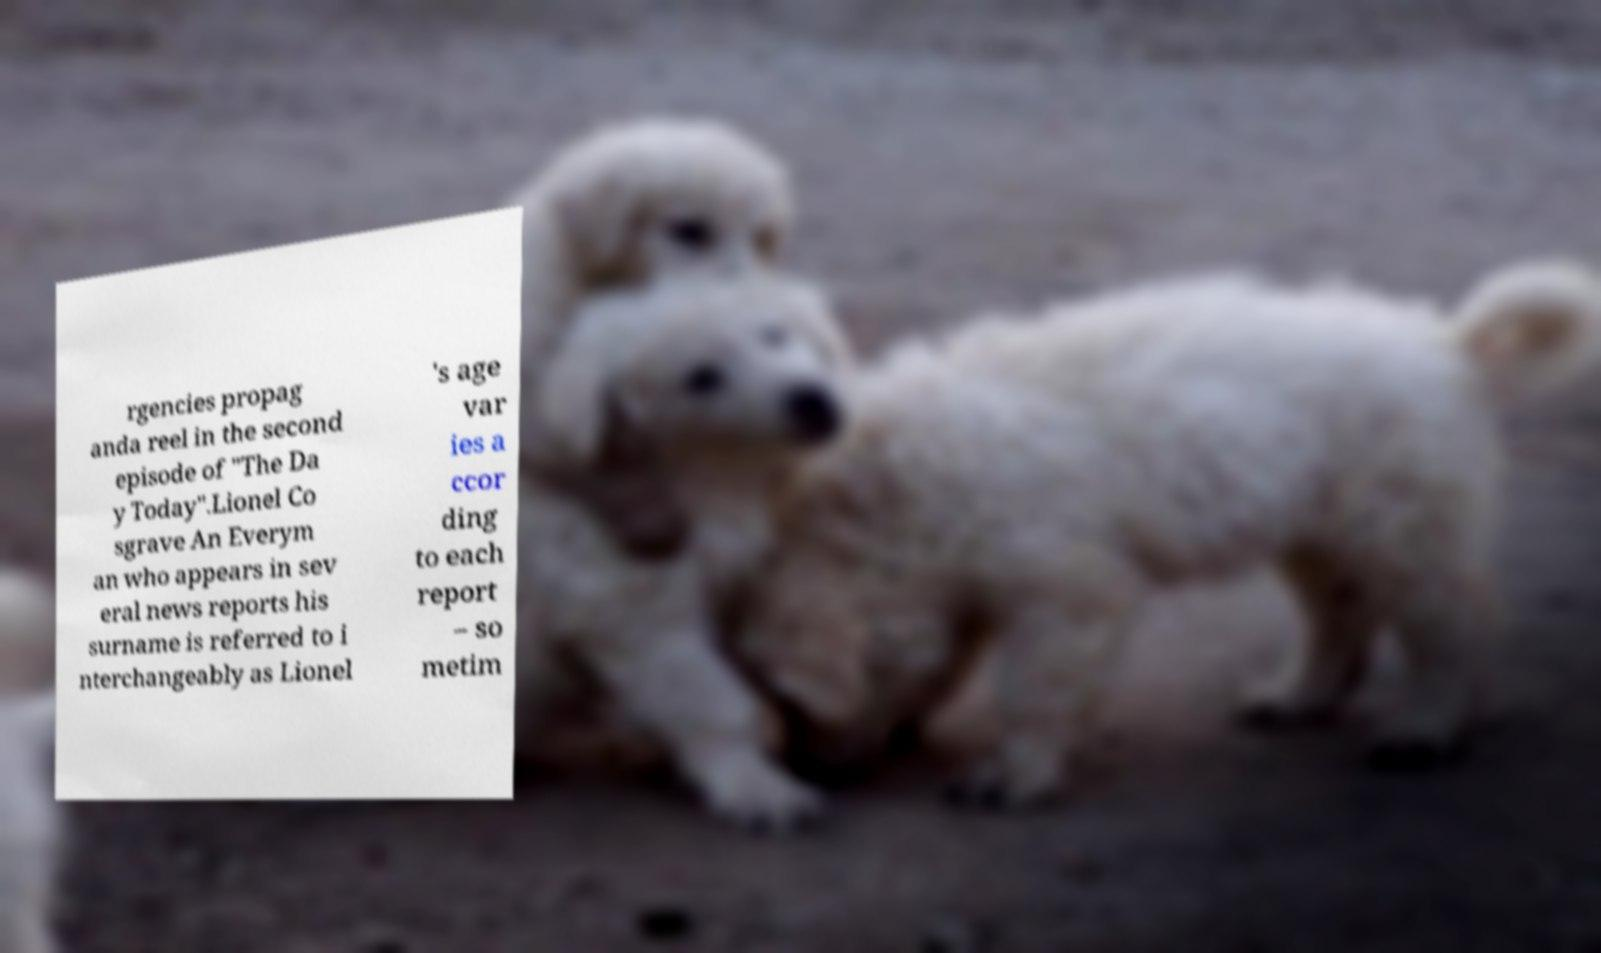Please read and relay the text visible in this image. What does it say? rgencies propag anda reel in the second episode of "The Da y Today".Lionel Co sgrave An Everym an who appears in sev eral news reports his surname is referred to i nterchangeably as Lionel 's age var ies a ccor ding to each report – so metim 